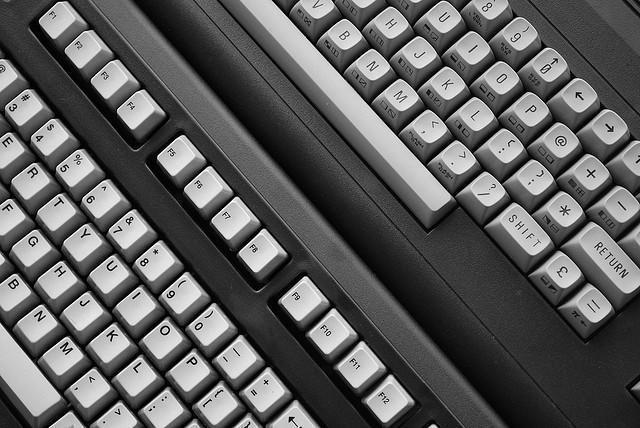How many keyboards are there?
Give a very brief answer. 2. How many Function keys are on the keyboards?
Give a very brief answer. 12. How many keyboards are in the photo?
Give a very brief answer. 2. How many girl goats are there?
Give a very brief answer. 0. 